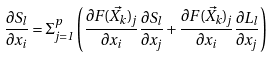Convert formula to latex. <formula><loc_0><loc_0><loc_500><loc_500>\frac { \partial S _ { l } } { \partial x _ { i } } = \Sigma _ { j = 1 } ^ { p } \left ( \frac { \partial F ( \vec { X _ { k } } ) _ { j } } { \partial x _ { i } } \frac { \partial S _ { l } } { \partial x _ { j } } + \frac { \partial F ( \vec { X _ { k } } ) _ { j } } { \partial x _ { i } } \frac { \partial L _ { l } } { \partial x _ { j } } \right )</formula> 